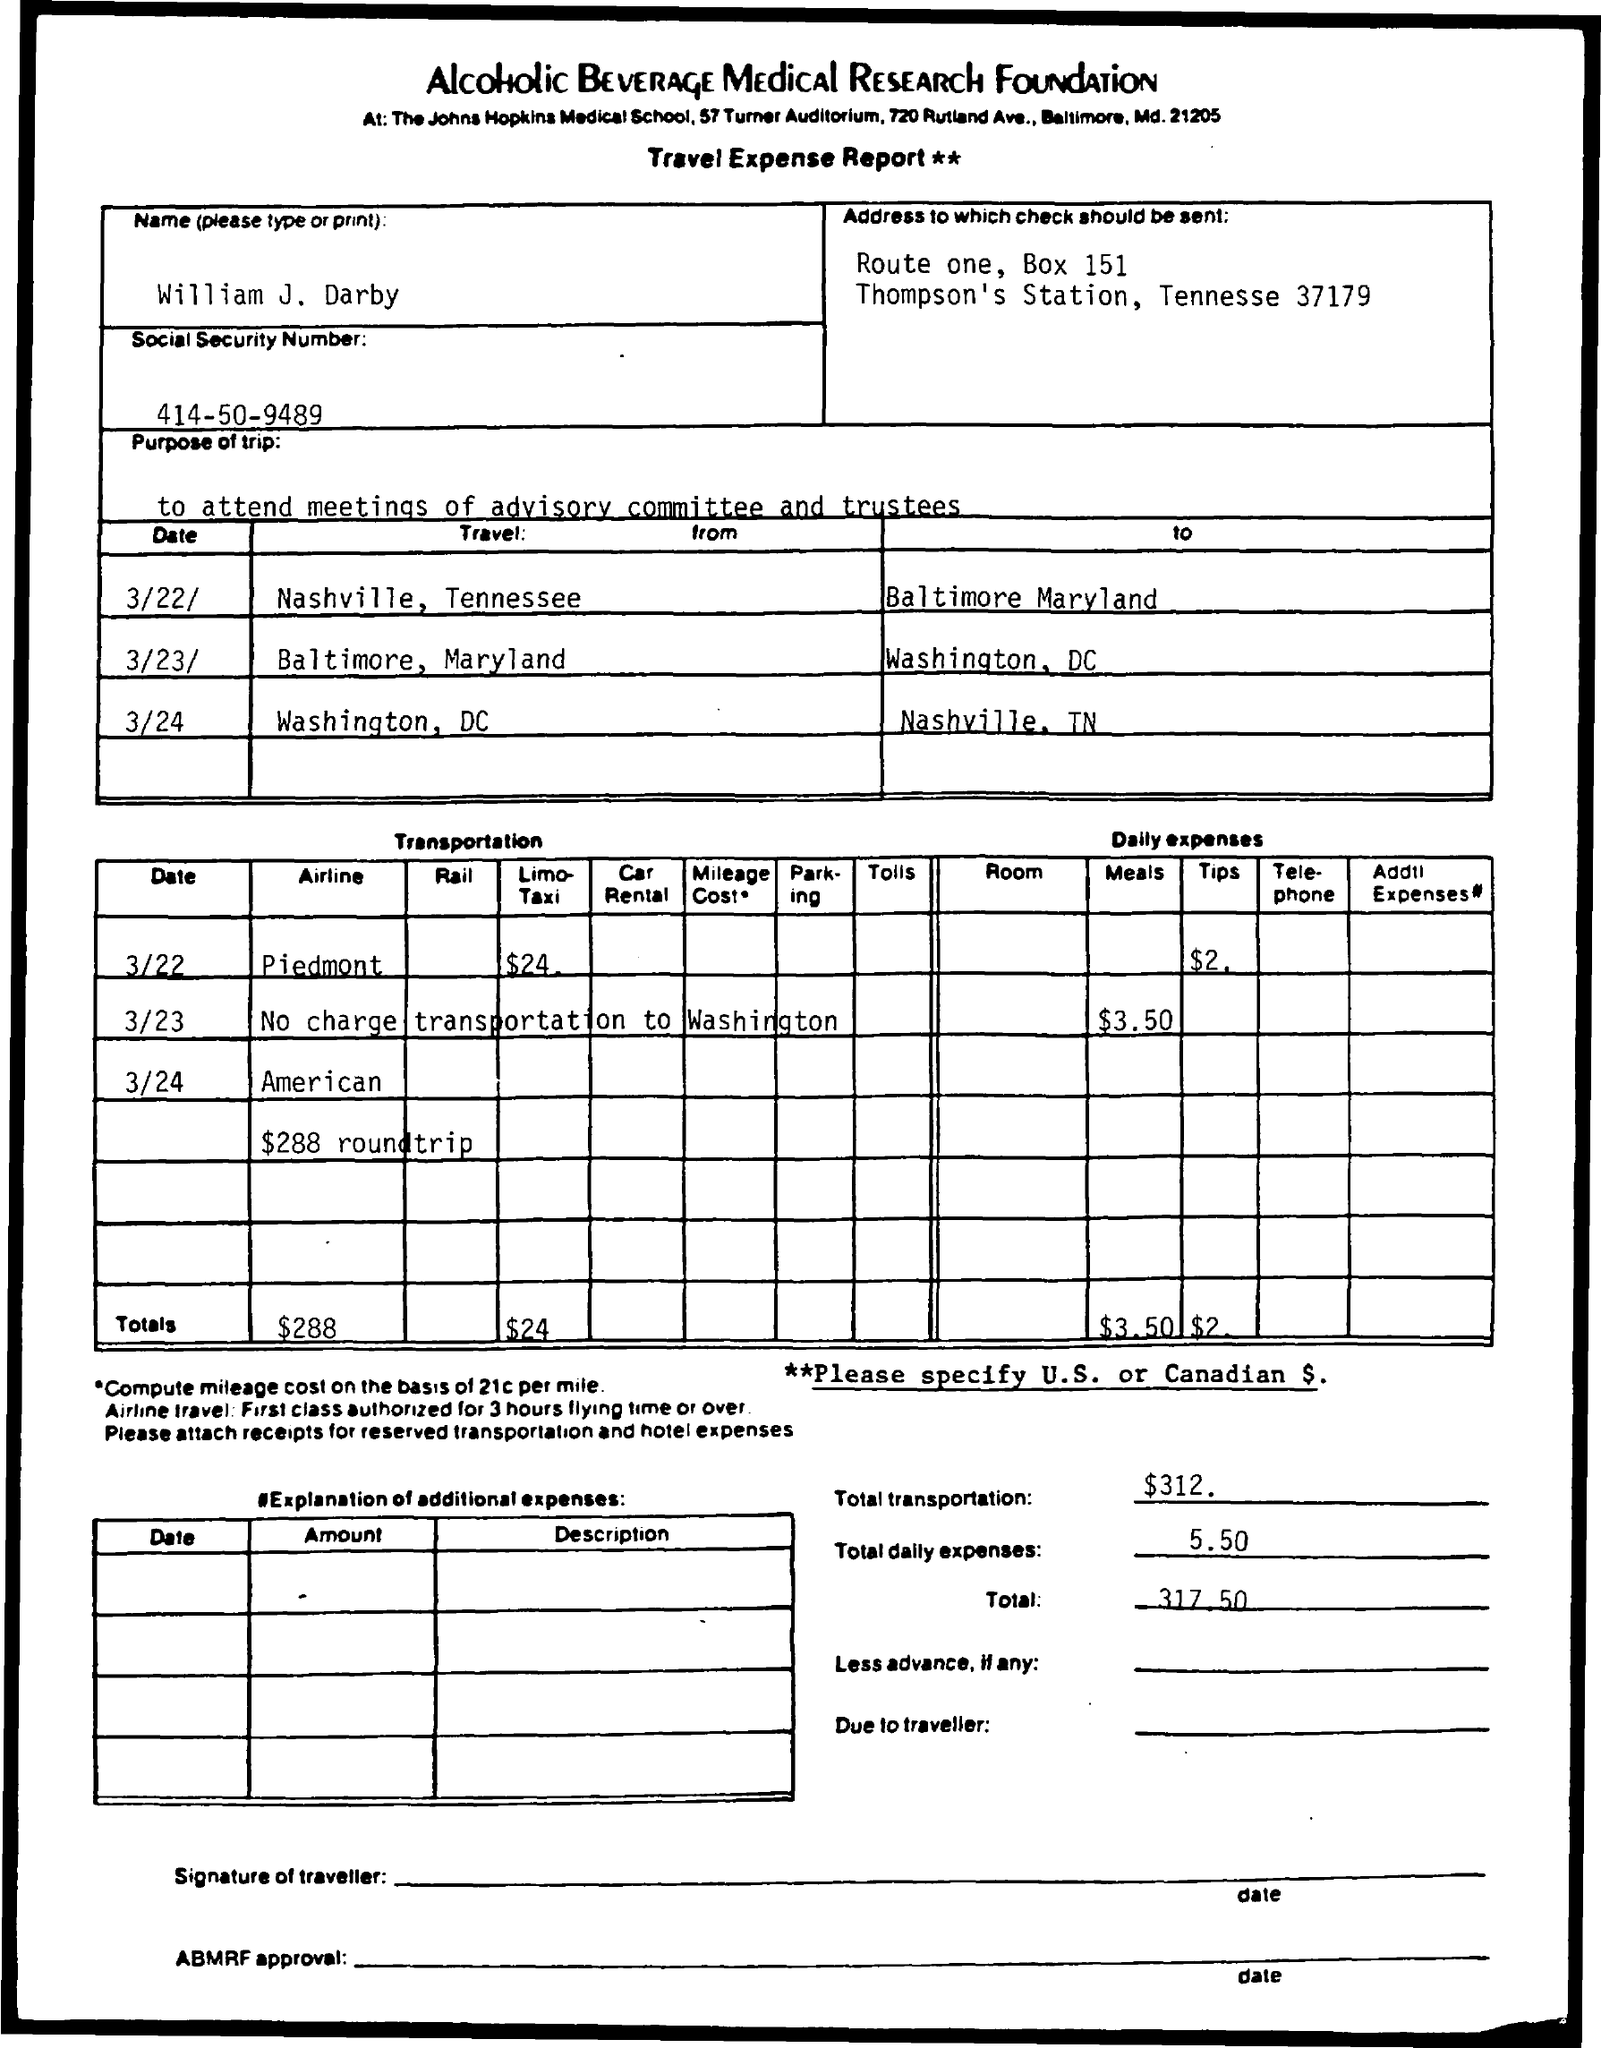Give some essential details in this illustration. The purpose of the trip mentioned in the document is to attend meetings of the advisory committee and the trustees. The document mentions a report named "Travel expense report. The total transportation amount mentioned in the document is $312. The Alcoholic Beverage Medical Research Foundation is mentioned in the document. The double star marks include a condition that needs to be specified, either in U.S. or Canadian dollars. 